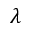Convert formula to latex. <formula><loc_0><loc_0><loc_500><loc_500>\lambda</formula> 